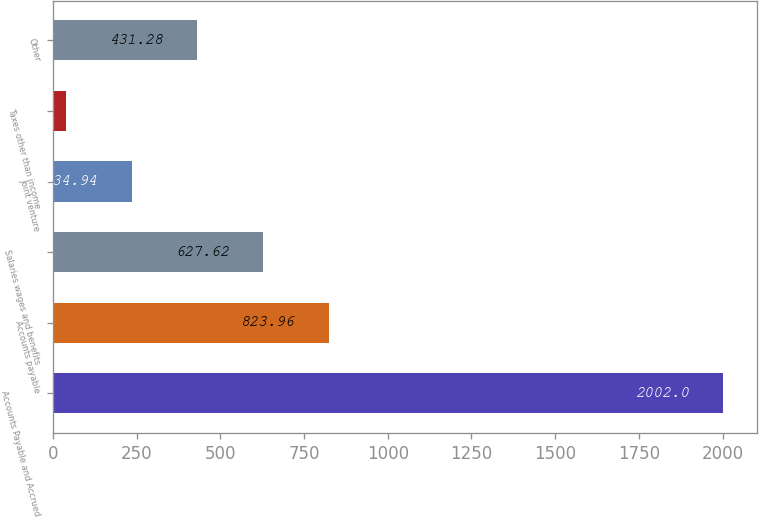<chart> <loc_0><loc_0><loc_500><loc_500><bar_chart><fcel>Accounts Payable and Accrued<fcel>Accounts payable<fcel>Salaries wages and benefits<fcel>Joint venture<fcel>Taxes other than income<fcel>Other<nl><fcel>2002<fcel>823.96<fcel>627.62<fcel>234.94<fcel>38.6<fcel>431.28<nl></chart> 